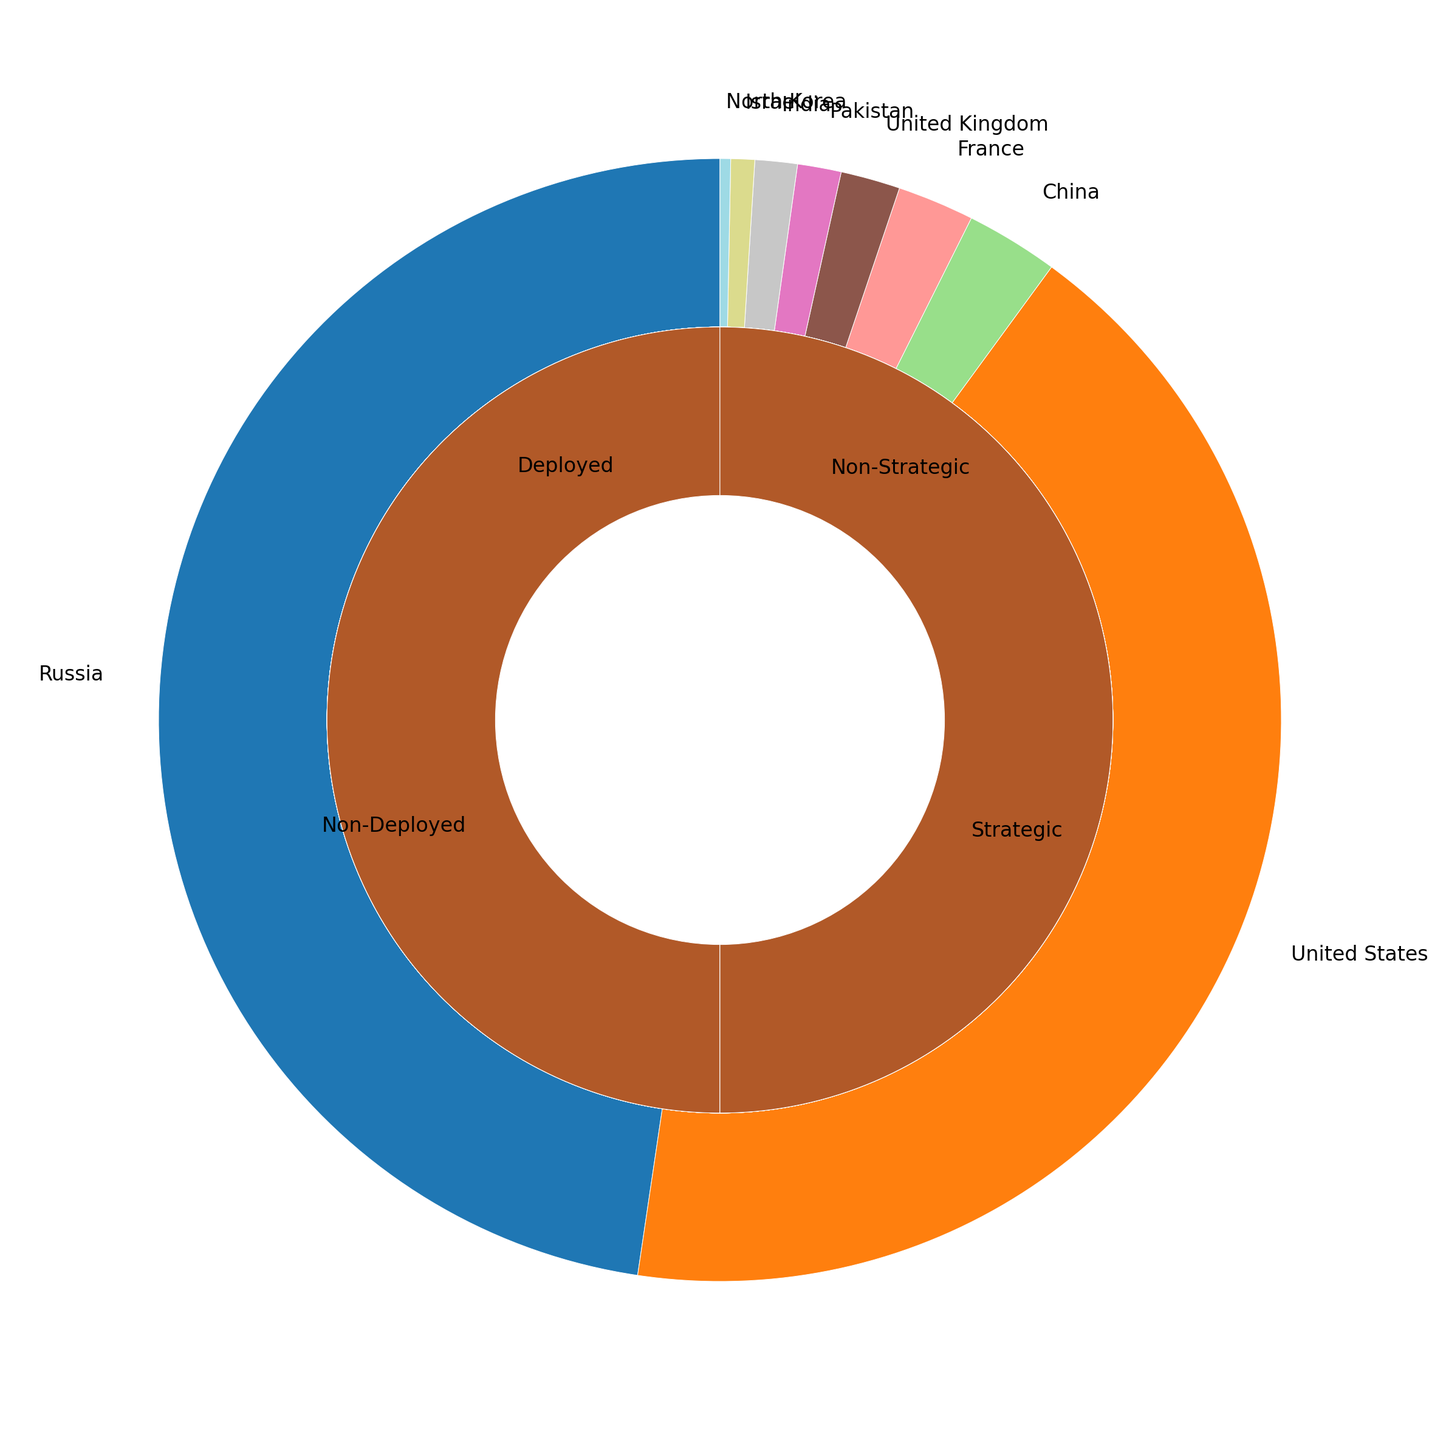How many total warheads do the top two countries have combined? To find the combined total, we add the total warheads of Russia and the United States. From the data, Russia has 6255 warheads and the United States has 5550 warheads. 6255 + 5550 = 11805.
Answer: 11805 Which country has the highest number of deployed warheads? By comparing the deployed warheads of each country, the United States has the highest number with 1800 deployed warheads, as opposed to Russia's 1575, the next highest.
Answer: United States Among the non-deployed warheads, which country has the least, and how many do they have? By analyzing the number of non-deployed warheads, France has the least with only 10 non-deployed warheads.
Answer: France, 10 Which countries have no deployed warheads? From the data, China, Pakistan, India, Israel, and North Korea all have 0 deployed warheads.
Answer: China, Pakistan, India, Israel, North Korea What is the difference in the number of strategic warheads between Russia and the United States? Russia has 4600 strategic warheads and the United States has 3700. The difference is calculated as 4600 - 3700 = 900.
Answer: 900 How many countries have non-strategic warheads? From the figure, Russia, the United States, China, France, the United Kingdom, Israel, and North Korea have non-strategic warheads, totaling 7 countries.
Answer: 7 Which country has the largest number of non-strategic warheads, and how many do they have? By looking at the numbers for non-strategic warheads, the United States has the most, with 1850 non-strategic warheads.
Answer: United States, 1850 What is the total number of strategic and non-strategic warheads for China? China has 230 strategic and 120 non-strategic warheads. Summing these numbers, 230 + 120 equals 350.
Answer: 350 